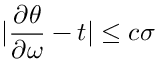<formula> <loc_0><loc_0><loc_500><loc_500>| \frac { \partial \theta } { \partial \omega } - t | \leq c \sigma</formula> 